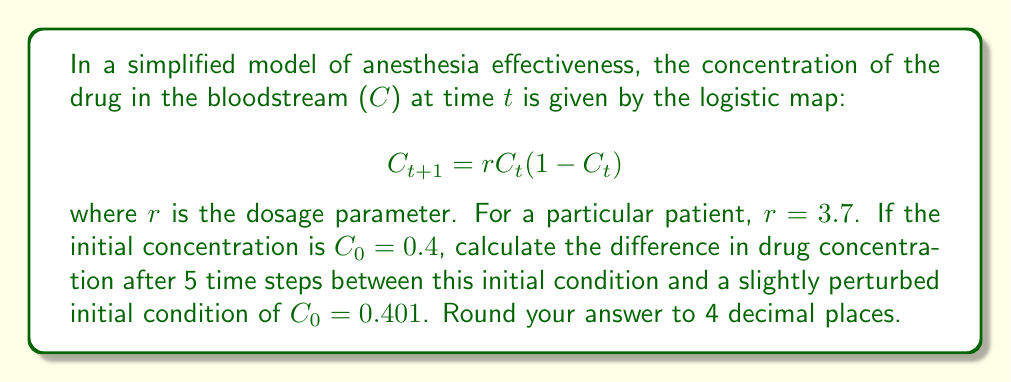Show me your answer to this math problem. Let's approach this step-by-step:

1) First, we need to calculate the concentrations for 5 time steps for both initial conditions.

2) For $C_0 = 0.4$:
   $C_1 = 3.7 * 0.4 * (1-0.4) = 0.888$
   $C_2 = 3.7 * 0.888 * (1-0.888) = 0.3685$
   $C_3 = 3.7 * 0.3685 * (1-0.3685) = 0.8614$
   $C_4 = 3.7 * 0.8614 * (1-0.8614) = 0.4432$
   $C_5 = 3.7 * 0.4432 * (1-0.4432) = 0.9139$

3) For $C_0 = 0.401$:
   $C_1 = 3.7 * 0.401 * (1-0.401) = 0.8889$
   $C_2 = 3.7 * 0.8889 * (1-0.8889) = 0.3659$
   $C_3 = 3.7 * 0.3659 * (1-0.3659) = 0.8597$
   $C_4 = 3.7 * 0.8597 * (1-0.8597) = 0.4469$
   $C_5 = 3.7 * 0.4469 * (1-0.4469) = 0.9146$

4) Now, we calculate the difference after 5 time steps:
   $|C_5(\text{initial} = 0.4) - C_5(\text{initial} = 0.401)|$
   $= |0.9139 - 0.9146| = 0.0007$

5) Rounding to 4 decimal places gives 0.0007.

This small difference after only 5 iterations, resulting from a tiny change in initial conditions, demonstrates the butterfly effect in chaotic systems like anesthesia dosing.
Answer: 0.0007 